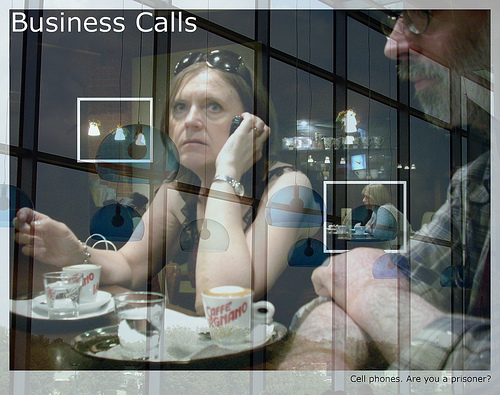Are there either balls or helmets? No, there are neither balls nor helmets present in the image. 